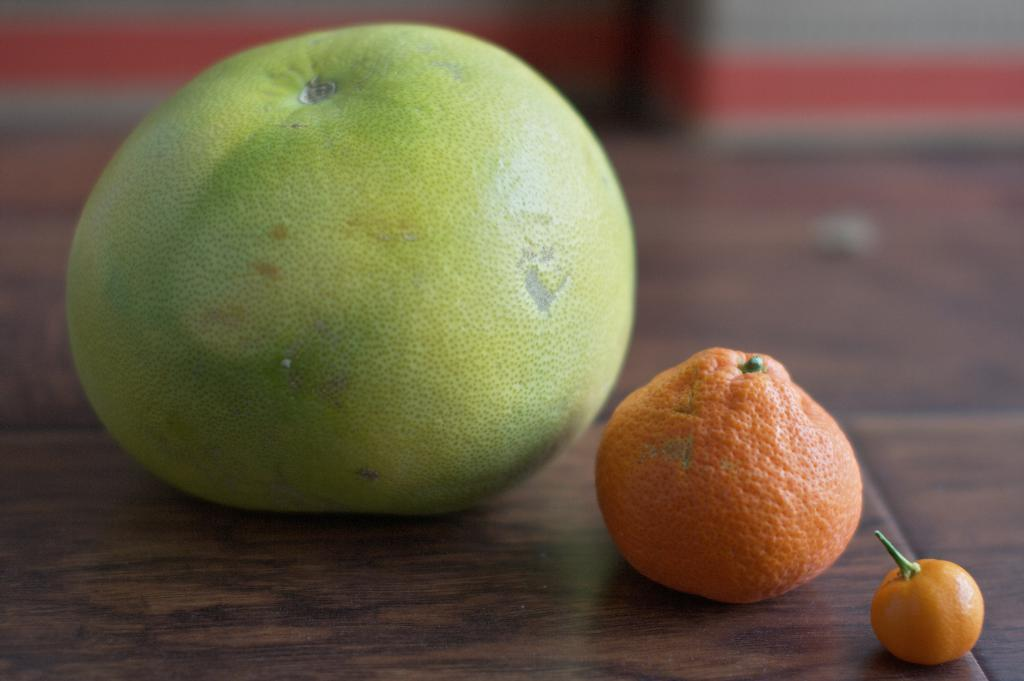What type of food can be seen in the image? There are fruits in the image. Can you describe the background of the image? The background of the image is blurry. What type of lock is visible in the image? There is no lock present in the image; it features fruits and a blurry background. Can you describe the beetle crawling on the fruits in the image? There is no beetle present in the image; it only features fruits and a blurry background. 